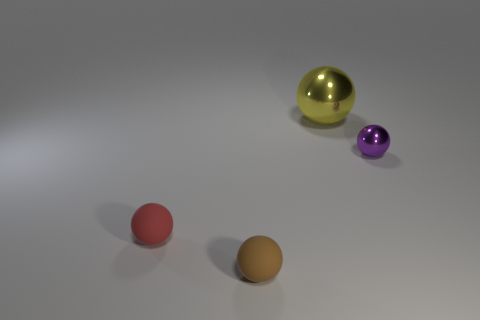What material is the ball that is to the right of the brown matte thing and on the left side of the tiny purple metallic object?
Your response must be concise. Metal. Do the rubber thing right of the small red rubber object and the metallic sphere to the right of the large metallic ball have the same color?
Make the answer very short. No. How many gray things are either large matte cylinders or small metal things?
Keep it short and to the point. 0. Are there fewer big yellow things that are in front of the large shiny ball than rubber spheres that are to the right of the small red matte thing?
Offer a terse response. Yes. Is there a red matte ball of the same size as the purple object?
Your response must be concise. Yes. There is a rubber object that is in front of the red thing; is it the same size as the purple shiny object?
Give a very brief answer. Yes. Is the number of large purple matte cubes greater than the number of metallic balls?
Your answer should be compact. No. Are there any tiny brown matte objects of the same shape as the red object?
Provide a short and direct response. Yes. There is a thing that is behind the purple shiny object; what shape is it?
Your answer should be very brief. Sphere. There is a shiny ball that is to the right of the large metallic ball to the right of the tiny red matte object; how many small metallic things are on the right side of it?
Provide a succinct answer. 0. 